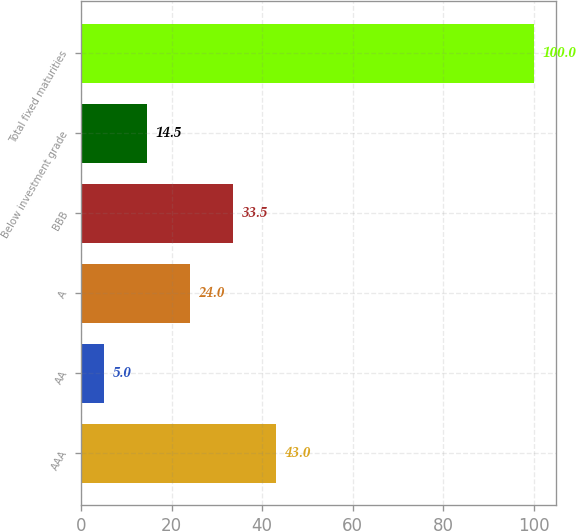<chart> <loc_0><loc_0><loc_500><loc_500><bar_chart><fcel>AAA<fcel>AA<fcel>A<fcel>BBB<fcel>Below investment grade<fcel>Total fixed maturities<nl><fcel>43<fcel>5<fcel>24<fcel>33.5<fcel>14.5<fcel>100<nl></chart> 